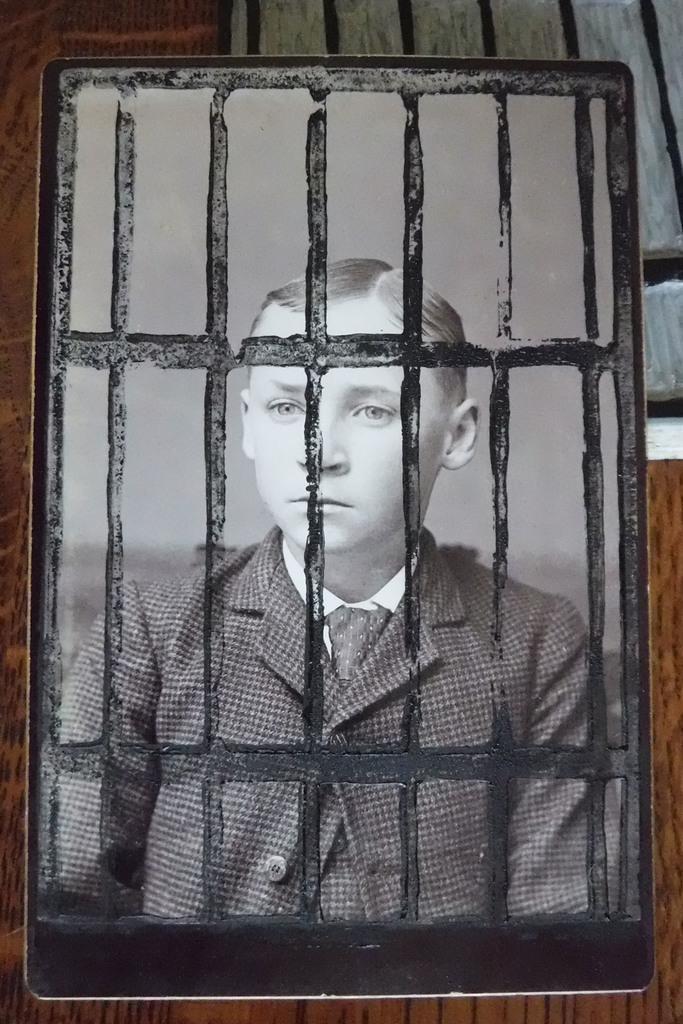Can you describe this image briefly? In the image there is a portrait of a boy kept on a table. 